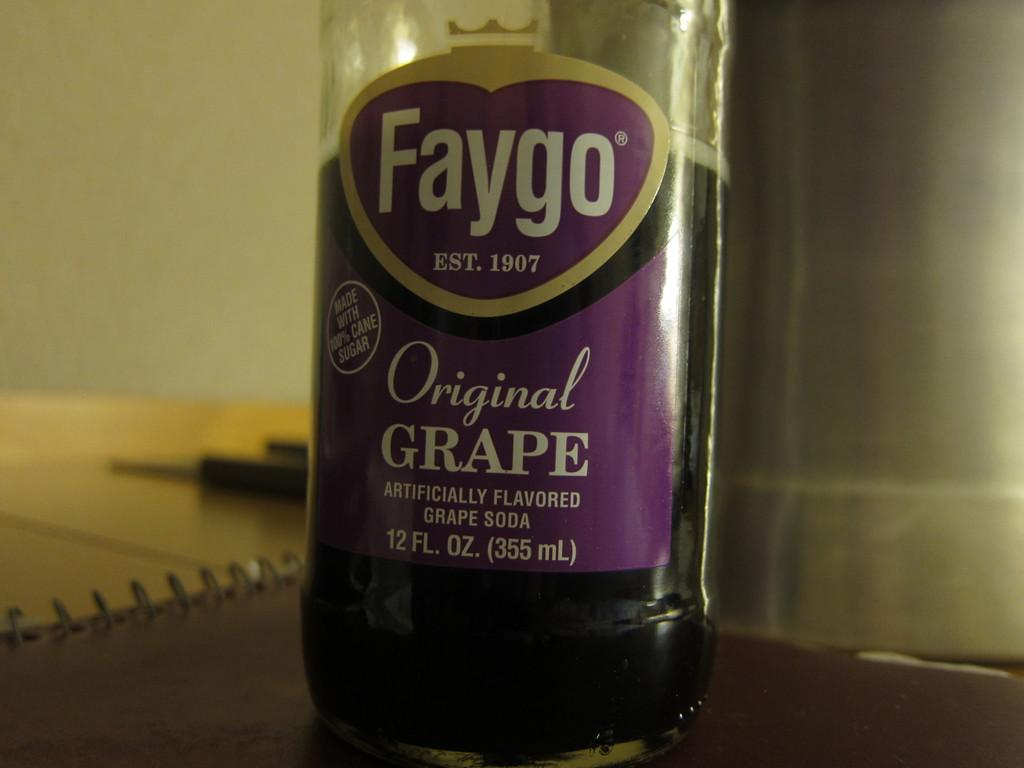Provide a one-sentence caption for the provided image. A 12 ounce bottle of Faygo grape soda. 